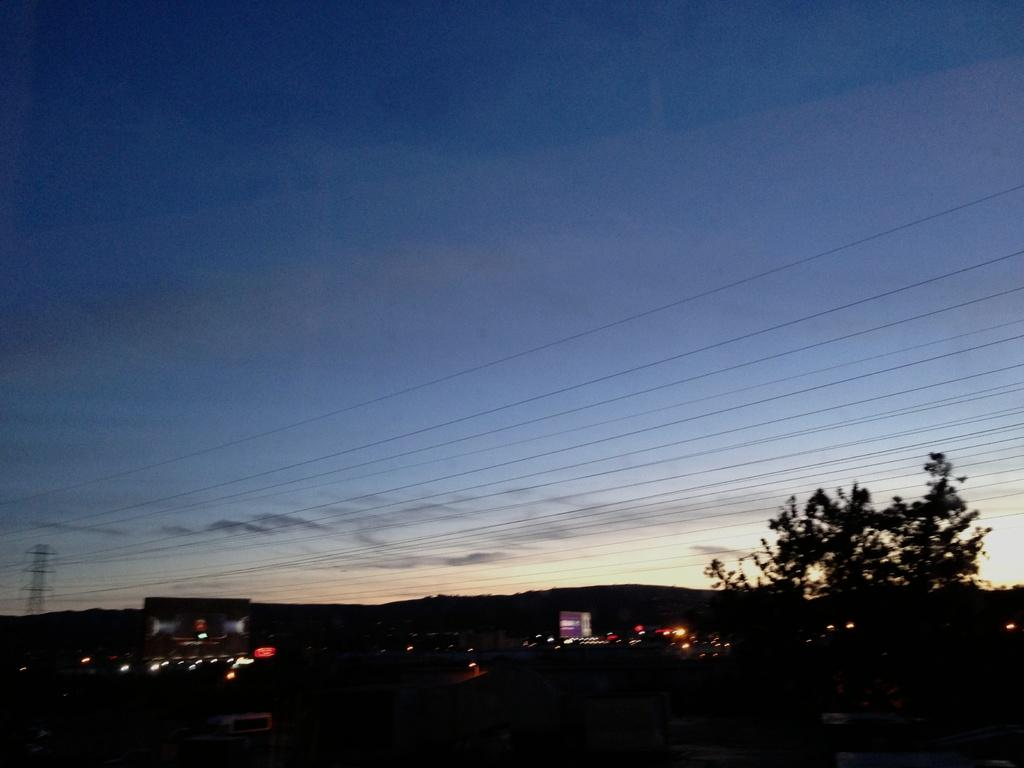What can be seen on the left side of the image? There are lights on the left side of the image. What is located on the right side of the image? There is a tree on the right side of the image. What is present in the middle of the image? Power cables are present in the middle of the image. What is visible at the top of the image? The sky is visible at the top of the image. What is the taste of the lights in the image? The taste of the lights cannot be determined from the image, as lights do not have a taste. 